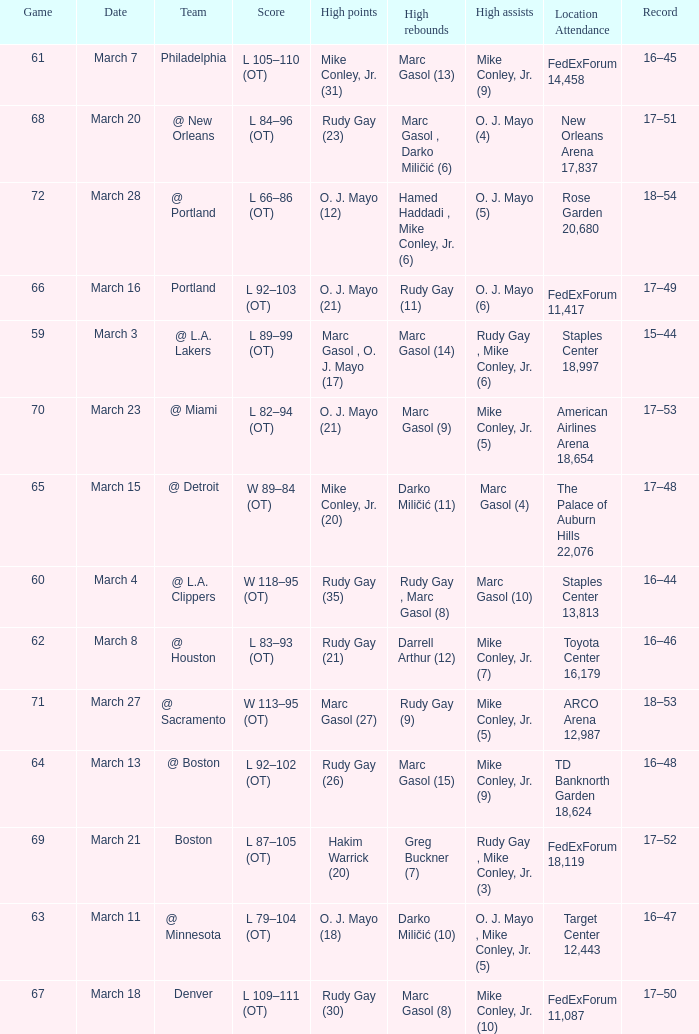What was the location and attendance for game 60? Staples Center 13,813. 